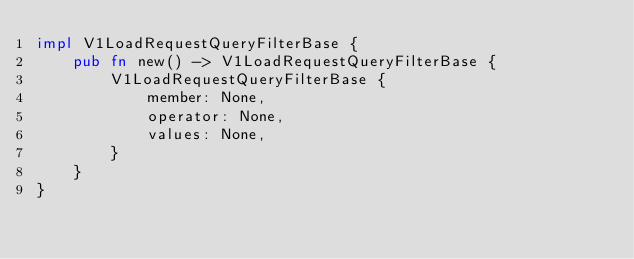Convert code to text. <code><loc_0><loc_0><loc_500><loc_500><_Rust_>impl V1LoadRequestQueryFilterBase {
    pub fn new() -> V1LoadRequestQueryFilterBase {
        V1LoadRequestQueryFilterBase {
            member: None,
            operator: None,
            values: None,
        }
    }
}
</code> 